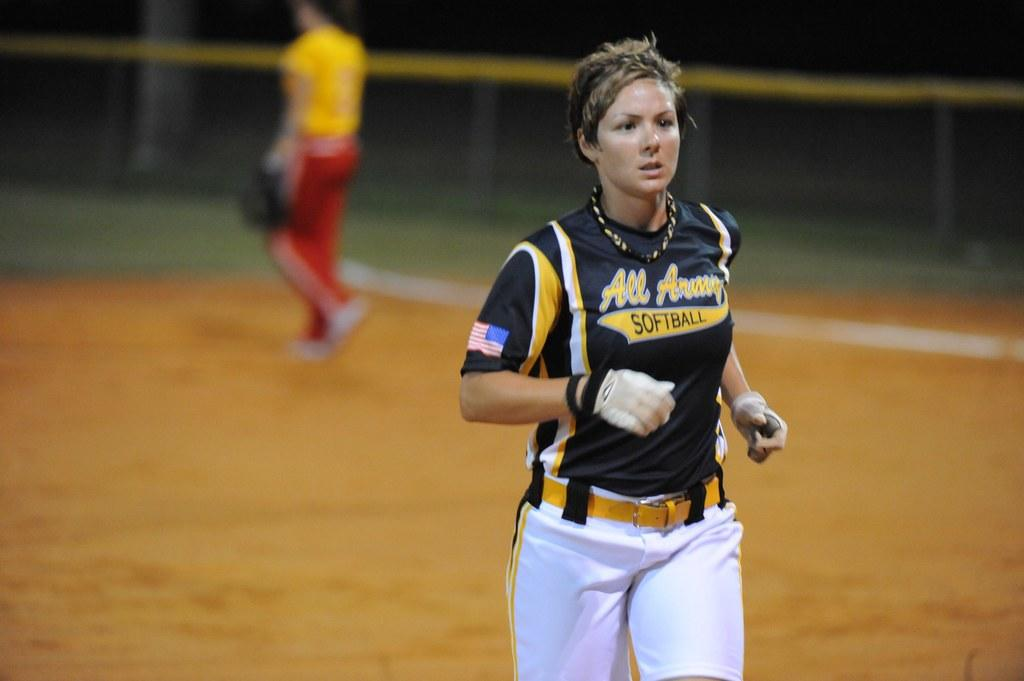<image>
Relay a brief, clear account of the picture shown. A woman jogs while wearing an All Army softball jersey. 